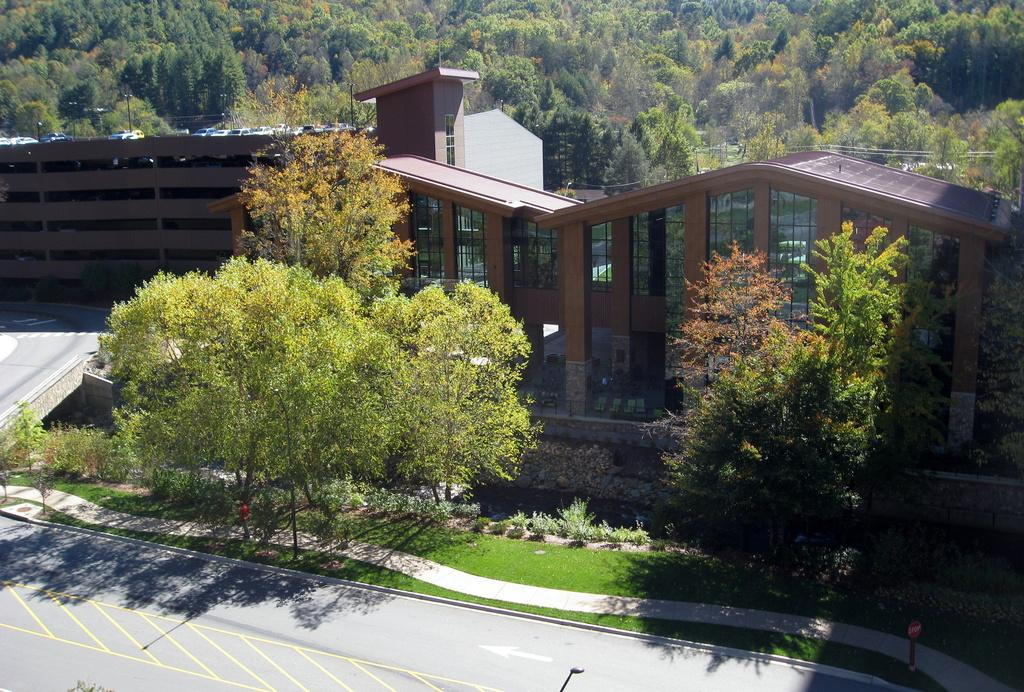What type of structures can be seen in the image? There are buildings in the image. What type of vegetation is present in the image? There are trees and plants in the image. What is the current interest rate for the plants in the image? There is no mention of interest rates in the image, as it features buildings and vegetation. 